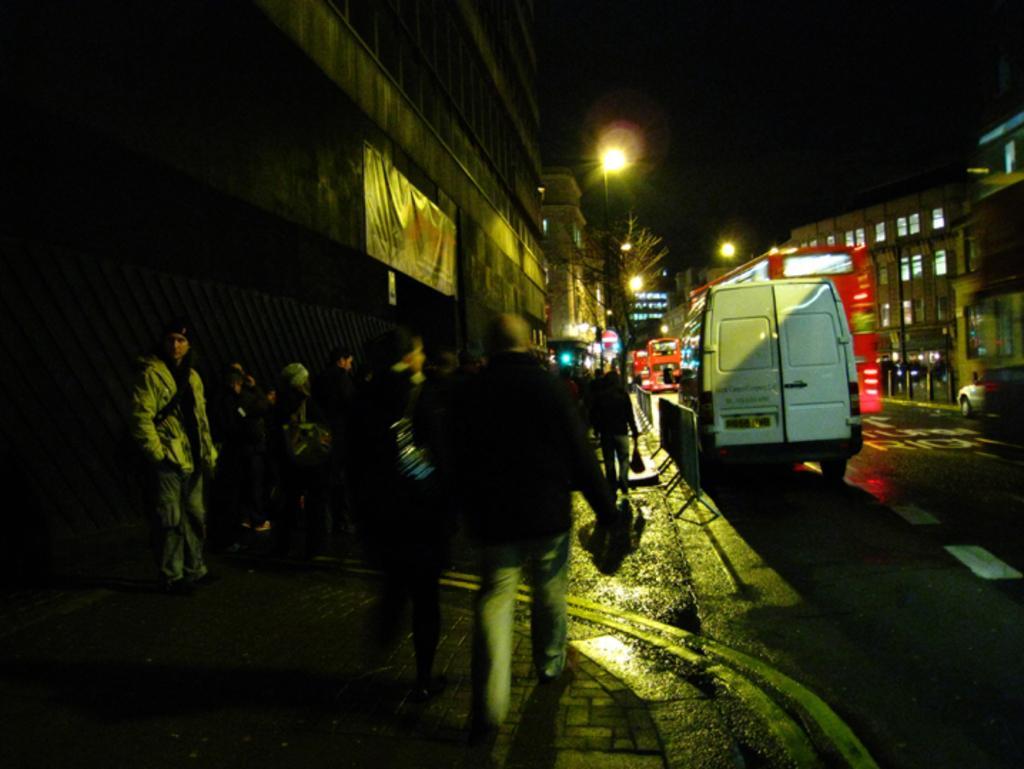Please provide a concise description of this image. There is a road. On the road there are vehicles. Near to the road there are barricades. There is a sidewalk. On the sidewalk there are many people. Also there are buildings with windows. In the back there are lights and tree. In the background it is dark. 